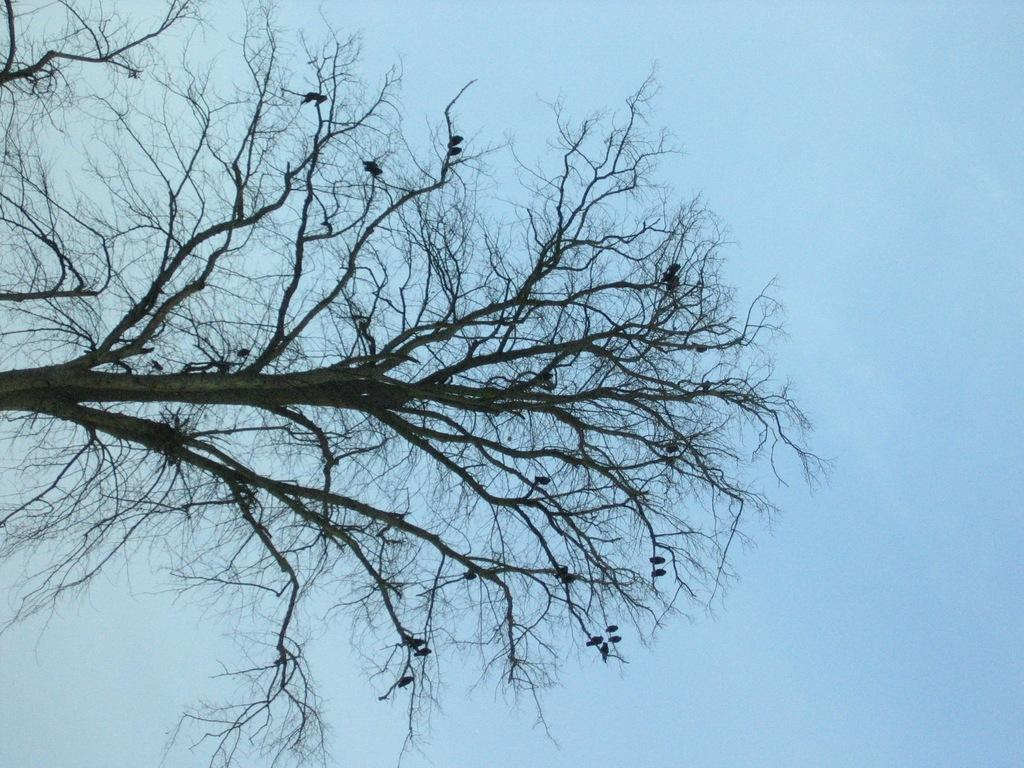What type of vegetation is present in the image? There are branches of a tree in the image. What can be seen in the background of the image? The sky is visible in the background of the image. What type of cable is connected to the door in the image? There is no cable or door present in the image; it only features branches of a tree and the sky. 